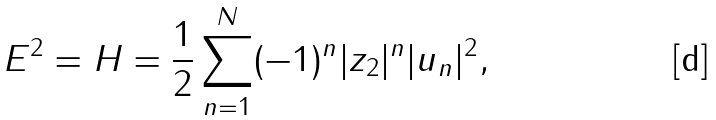Convert formula to latex. <formula><loc_0><loc_0><loc_500><loc_500>E ^ { 2 } = H = \frac { 1 } { 2 } \sum _ { n = 1 } ^ { N } ( - 1 ) ^ { n } | z _ { 2 } | ^ { n } | u _ { n } | ^ { 2 } ,</formula> 